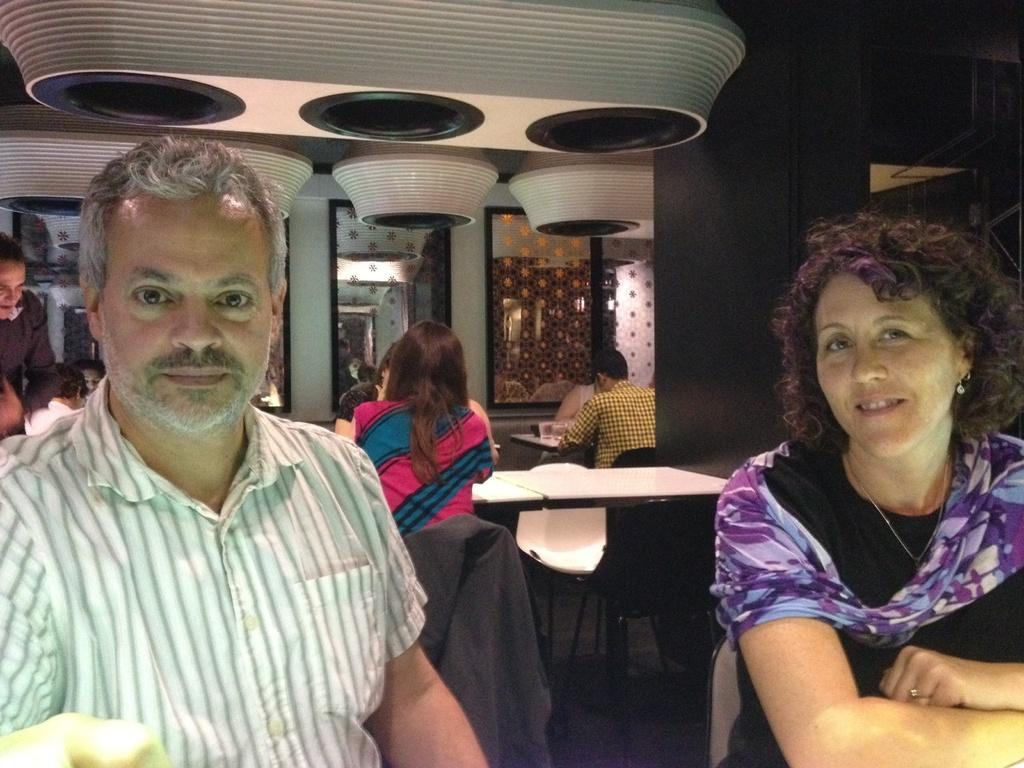How many people are sitting on the chair in the image? There are two people sitting on a chair in the image. Are there any other people visible in the image? Yes, there are other people sitting behind them. What type of snail can be seen crawling on the chair in the image? There is no snail present in the image; it only features people sitting on a chair. 